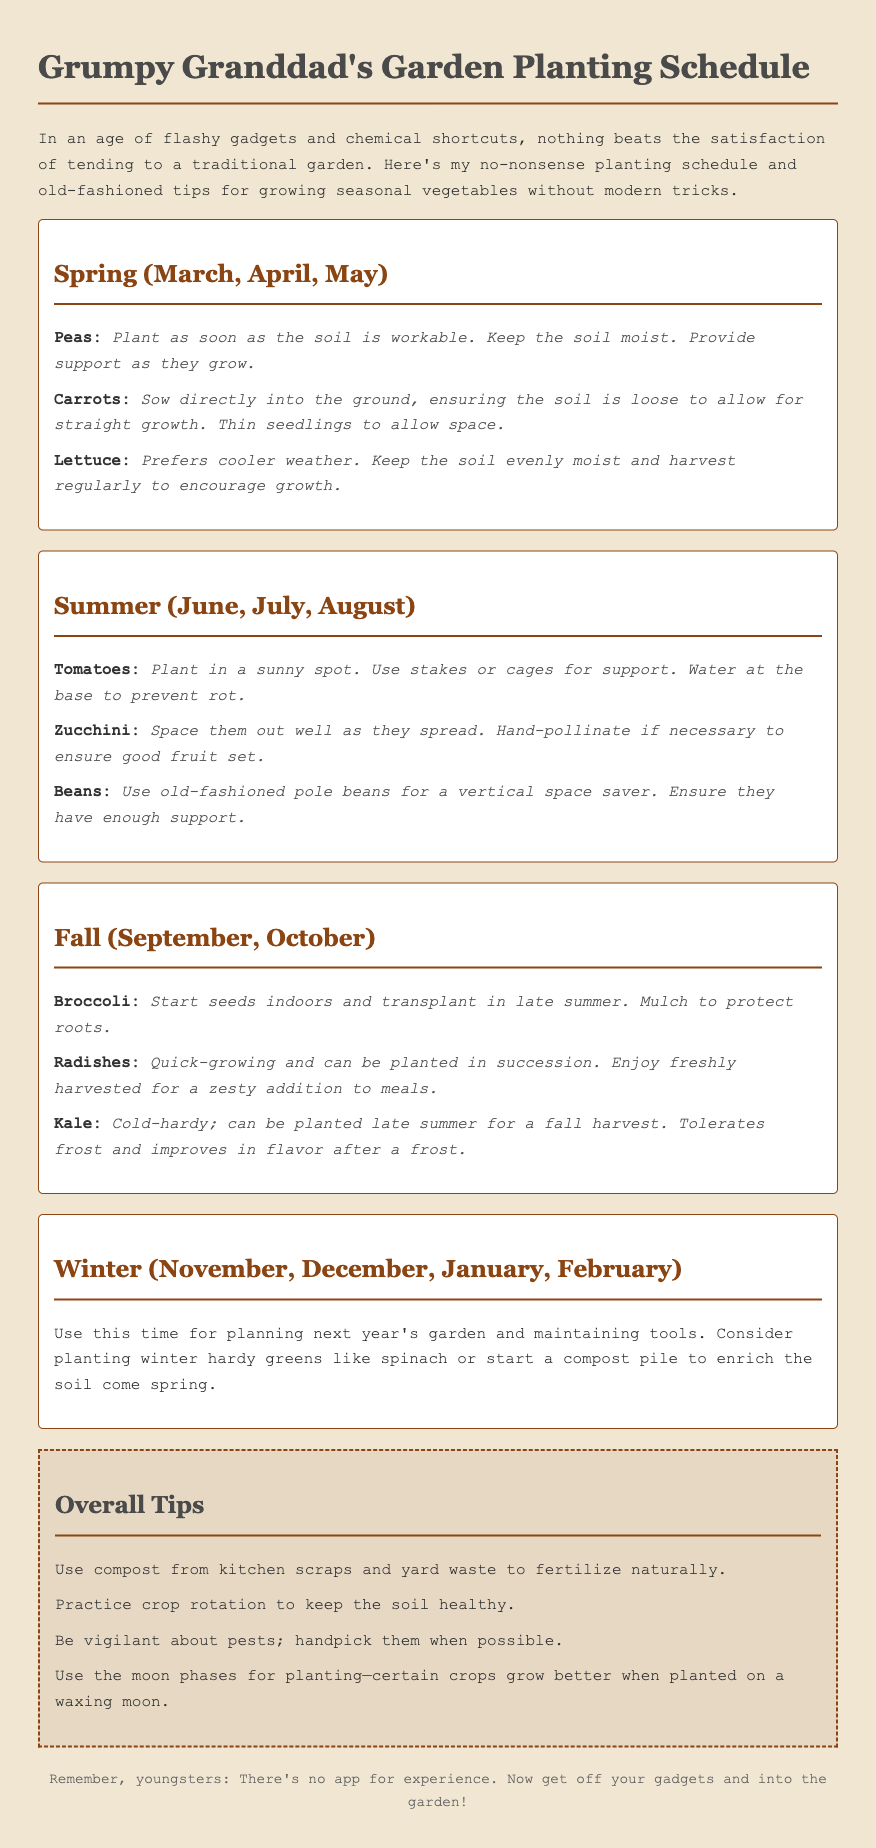What vegetables are planted in spring? The document lists peas, carrots, and lettuce as the spring vegetables.
Answer: peas, carrots, lettuce How should tomatoes be watered? The document advises watering tomatoes at the base to prevent rot.
Answer: at the base What is a tip for growing kale? The document states that kale tolerates frost and improves in flavor after frost.
Answer: improves in flavor after frost Which month is best for planting peas? The document suggests planting peas as soon as the soil is workable in March.
Answer: March What is one overall tip for gardening mentioned? One overall tip in the document is to use compost from kitchen scraps and yard waste.
Answer: compost from kitchen scraps and yard waste Which season is advised for planning next year's garden? The document indicates that winter is the time for planning the next year's garden.
Answer: winter What type of beans does the document recommend? The document recommends using old-fashioned pole beans for gardening.
Answer: old-fashioned pole beans How many months are covered in the planting schedule for winter? The document covers four months: November, December, January, and February.
Answer: four months 